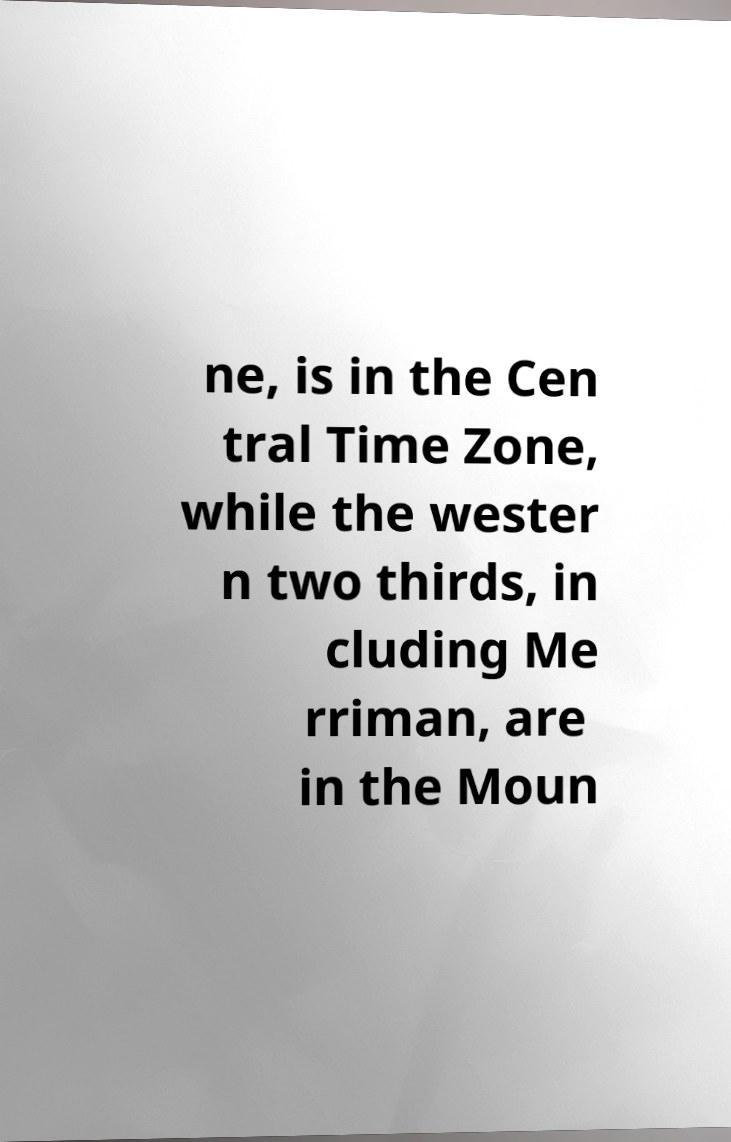For documentation purposes, I need the text within this image transcribed. Could you provide that? ne, is in the Cen tral Time Zone, while the wester n two thirds, in cluding Me rriman, are in the Moun 